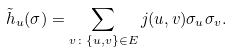<formula> <loc_0><loc_0><loc_500><loc_500>\tilde { h } _ { u } ( \sigma ) = \sum _ { v \colon \{ u , v \} \in E } j ( u , v ) \sigma _ { u } \sigma _ { v } .</formula> 